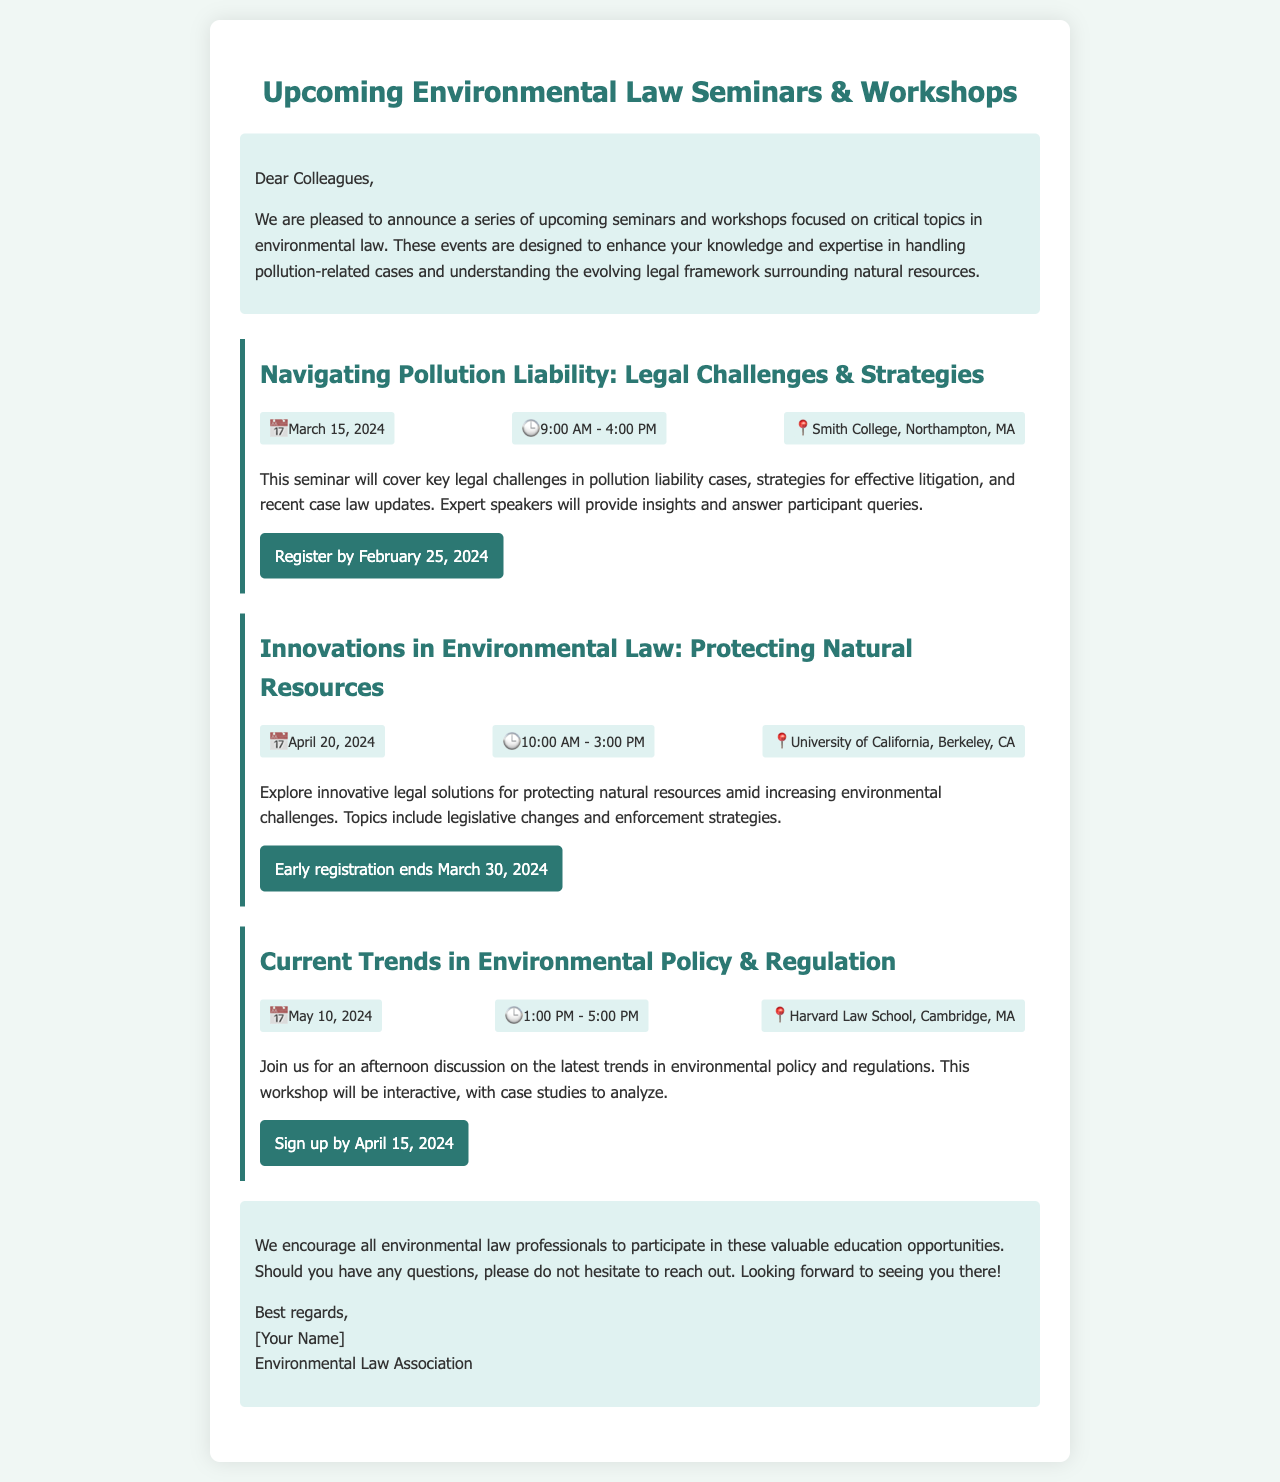What is the title of the first seminar? The title of the first seminar is found in the document, specifically in the section describing events.
Answer: Navigating Pollution Liability: Legal Challenges & Strategies When is the workshop on Current Trends in Environmental Policy & Regulation scheduled? The date of the workshop can be found in the event details section of the document.
Answer: May 10, 2024 Where will the Innovations in Environmental Law seminar take place? The location is specified in the event details for the seminar and provides specific address information.
Answer: University of California, Berkeley, CA What is the registration deadline for the first seminar? The registration deadline is mentioned in the call-to-action link of the event details.
Answer: February 25, 2024 How long is the Navigating Pollution Liability seminar? The duration can be inferred from the event details section detailing start and end times.
Answer: 7 hours What type of event is described in the newsletter? The document focuses on professional development events specifically targeting a legal audience.
Answer: Seminars & Workshops What is the registration link for the workshop on Current Trends in Environmental Policy & Regulation? The registration link is provided within the document for easy access to sign up.
Answer: https://www.environmentalpolicyforum.com/currenttrends What time does the Innovations in Environmental Law seminar start? The starting time is provided in the event details section of the document.
Answer: 10:00 AM Who is the author of the newsletter? The author is mentioned in the closing remarks of the document, indicating who is responsible for the correspondence.
Answer: [Your Name] 